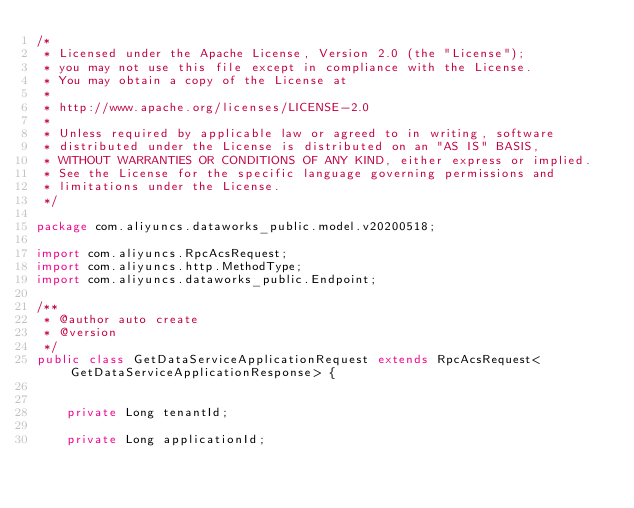Convert code to text. <code><loc_0><loc_0><loc_500><loc_500><_Java_>/*
 * Licensed under the Apache License, Version 2.0 (the "License");
 * you may not use this file except in compliance with the License.
 * You may obtain a copy of the License at
 *
 * http://www.apache.org/licenses/LICENSE-2.0
 *
 * Unless required by applicable law or agreed to in writing, software
 * distributed under the License is distributed on an "AS IS" BASIS,
 * WITHOUT WARRANTIES OR CONDITIONS OF ANY KIND, either express or implied.
 * See the License for the specific language governing permissions and
 * limitations under the License.
 */

package com.aliyuncs.dataworks_public.model.v20200518;

import com.aliyuncs.RpcAcsRequest;
import com.aliyuncs.http.MethodType;
import com.aliyuncs.dataworks_public.Endpoint;

/**
 * @author auto create
 * @version 
 */
public class GetDataServiceApplicationRequest extends RpcAcsRequest<GetDataServiceApplicationResponse> {
	   

	private Long tenantId;

	private Long applicationId;</code> 